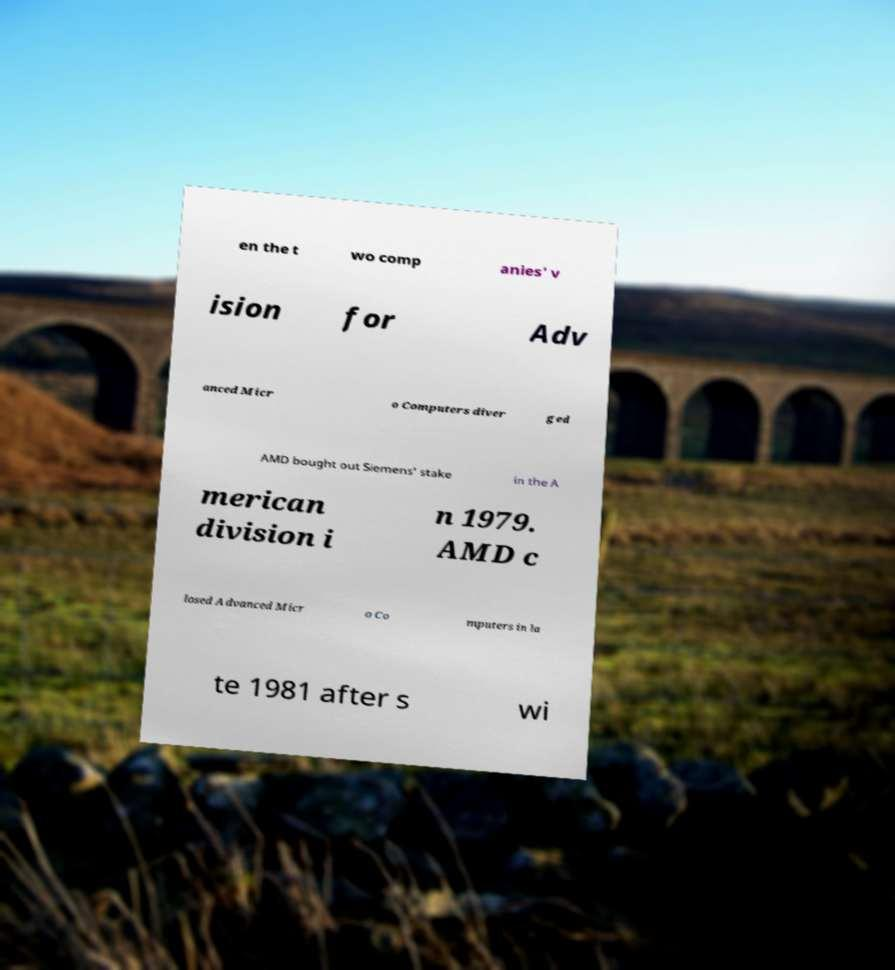Please identify and transcribe the text found in this image. en the t wo comp anies' v ision for Adv anced Micr o Computers diver ged AMD bought out Siemens' stake in the A merican division i n 1979. AMD c losed Advanced Micr o Co mputers in la te 1981 after s wi 